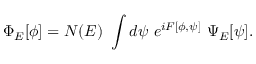Convert formula to latex. <formula><loc_0><loc_0><loc_500><loc_500>\Phi _ { E } [ \phi ] = N ( E ) \int d \psi e ^ { i F [ \phi , \psi ] } \Psi _ { E } [ \psi ] .</formula> 